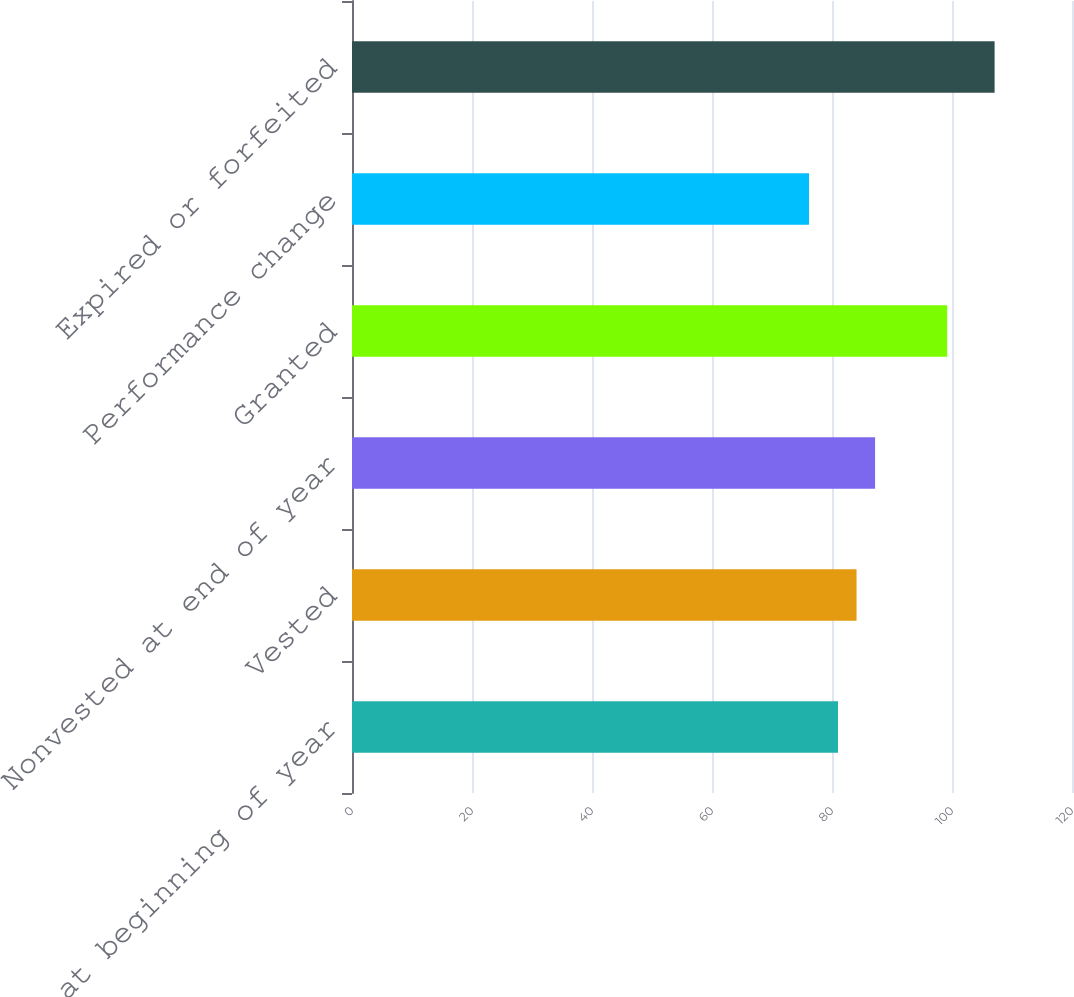Convert chart to OTSL. <chart><loc_0><loc_0><loc_500><loc_500><bar_chart><fcel>Nonvested at beginning of year<fcel>Vested<fcel>Nonvested at end of year<fcel>Granted<fcel>Performance change<fcel>Expired or forfeited<nl><fcel>81<fcel>84.09<fcel>87.18<fcel>99.2<fcel>76.17<fcel>107.1<nl></chart> 